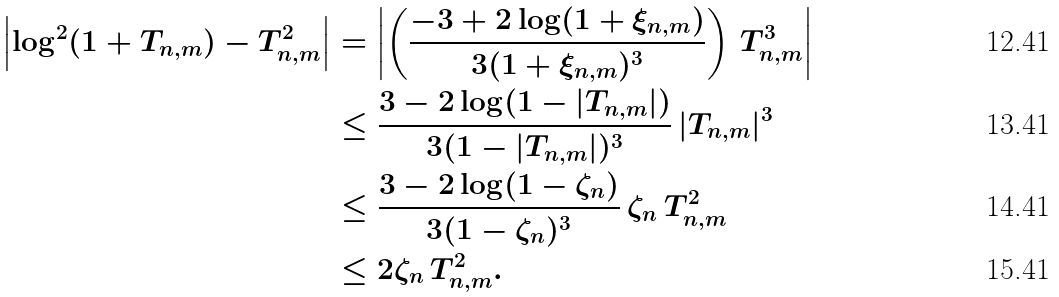Convert formula to latex. <formula><loc_0><loc_0><loc_500><loc_500>\left | \log ^ { 2 } ( 1 + T _ { n , m } ) - T _ { n , m } ^ { 2 } \right | & = \left | \left ( \frac { - 3 + 2 \log ( 1 + \xi _ { n , m } ) } { 3 ( 1 + \xi _ { n , m } ) ^ { 3 } } \right ) \, T _ { n , m } ^ { 3 } \right | \\ & \leq \frac { 3 - 2 \log ( 1 - | T _ { n , m } | ) } { 3 ( 1 - | T _ { n , m } | ) ^ { 3 } } \, | T _ { n , m } | ^ { 3 } \\ & \leq \frac { 3 - 2 \log ( 1 - \zeta _ { n } ) } { 3 ( 1 - \zeta _ { n } ) ^ { 3 } } \, \zeta _ { n } \, T _ { n , m } ^ { 2 } \\ & \leq 2 \zeta _ { n } \, T _ { n , m } ^ { 2 } .</formula> 